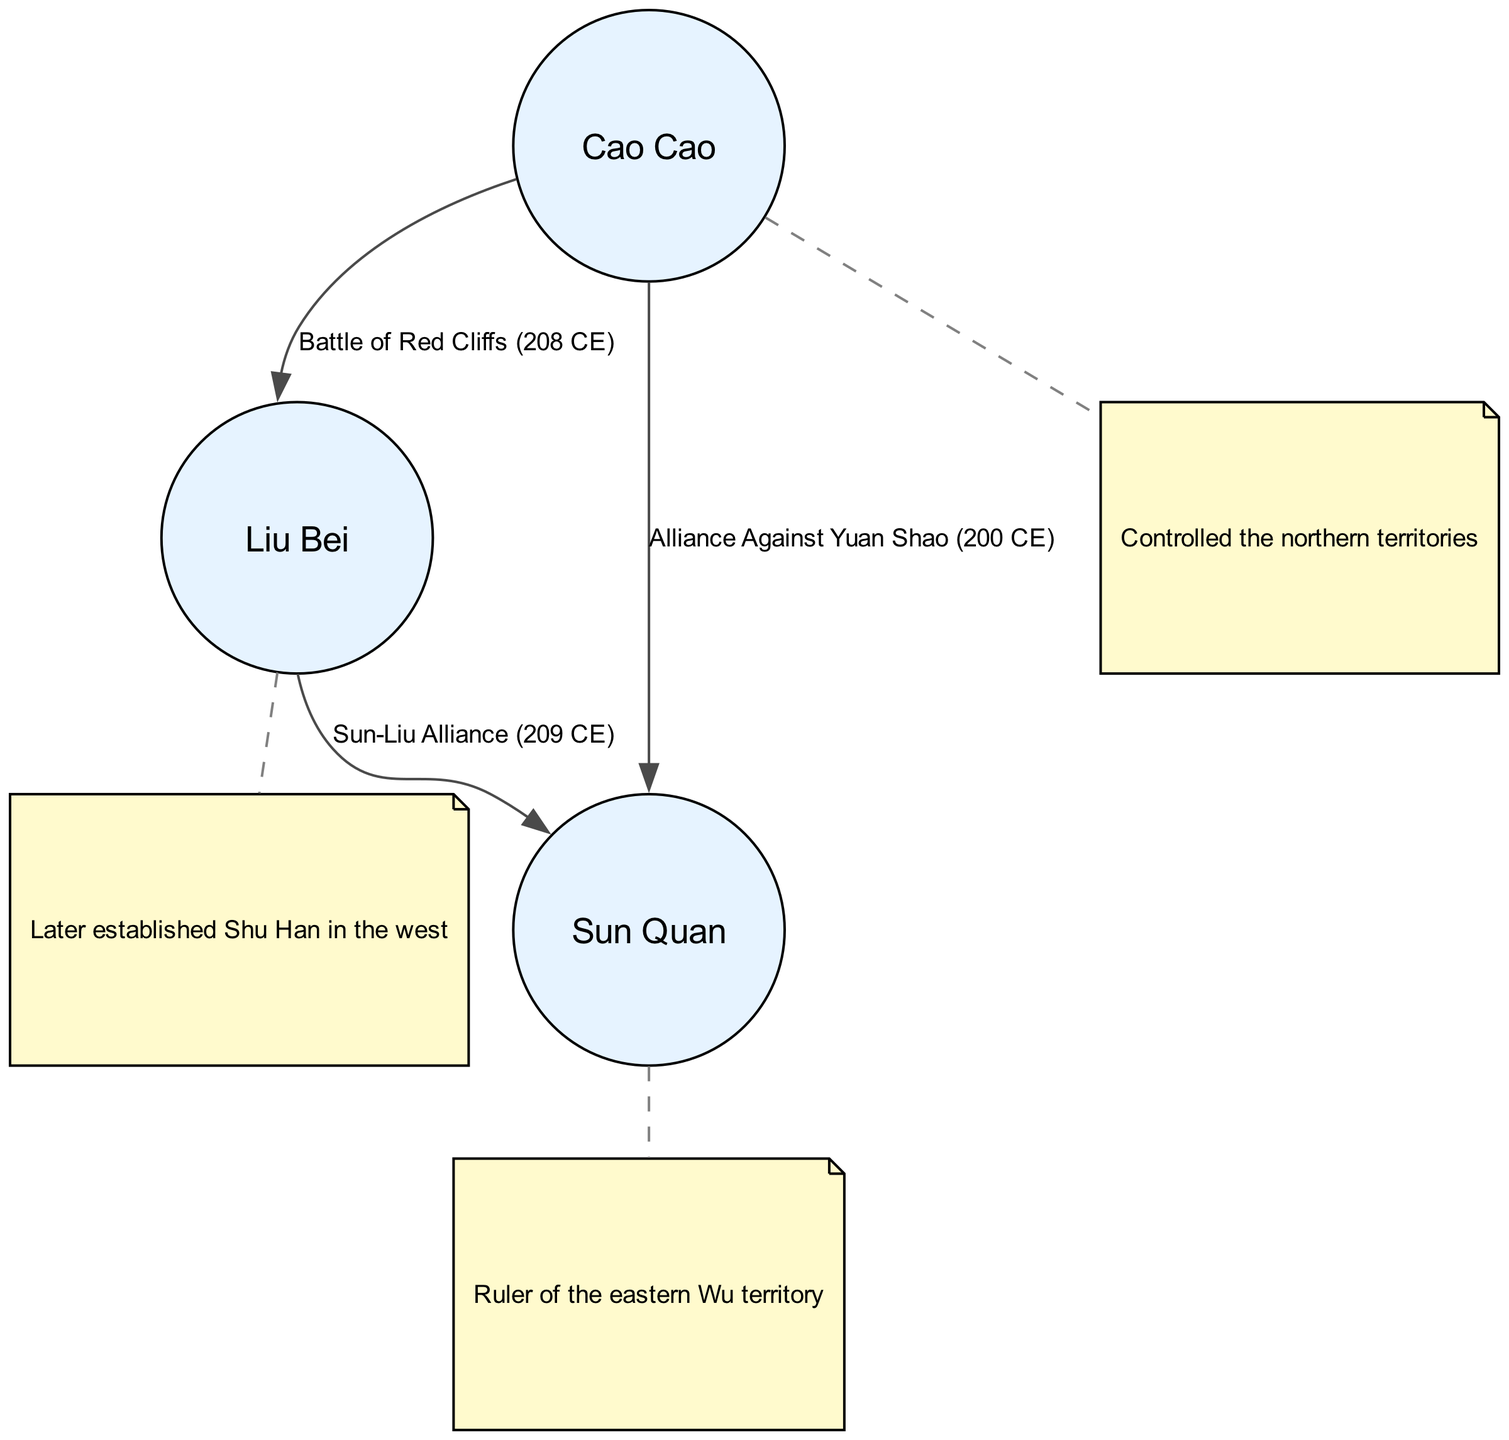What are the names of the three major warlords? The diagram includes three nodes labeled 'Cao Cao', 'Liu Bei', and 'Sun Quan', representing the major warlords of the Three Kingdoms period.
Answer: Cao Cao, Liu Bei, Sun Quan How many edges are in the diagram? The diagram has four edges: three representing battles or alliances and one for each annotation connection, leading to a total of four connections.
Answer: 4 What is the label of the edge between Cao Cao and Liu Bei? The edge connecting Cao Cao and Liu Bei is labeled 'Battle of Red Cliffs (208 CE)', indicating a significant conflict between the two warlords.
Answer: Battle of Red Cliffs (208 CE) Who controlled the northern territories? The annotation for Cao Cao states that he "Controlled the northern territories," indicating his significant geographical influence during this period.
Answer: Cao Cao What alliance was formed in 209 CE? The diagram indicates a connection labeled 'Sun-Liu Alliance (209 CE)' between Liu Bei and Sun Quan, denoting their collaboration against common enemies.
Answer: Sun-Liu Alliance (209 CE) Which warlord established Shu Han? The annotation related to Liu Bei explicitly mentions that he "Later established Shu Han in the west," indicating his role in forming a significant state in the Three Kingdoms period.
Answer: Liu Bei What year did Cao Cao and Sun Quan form an alliance? The edge labeled 'Alliance Against Yuan Shao (200 CE)' shows that Cao Cao and Sun Quan forged an alliance in the year 200 CE against a common adversary.
Answer: 200 CE Which territories did Sun Quan rule? The annotation for Sun Quan specifies that he was the "Ruler of the eastern Wu territory," identifying his geographical control during the Three Kingdoms period.
Answer: eastern Wu territory Who is depicted as the key figure in the northern territories? The diagram shows an annotation for Cao Cao stating he "Controlled the northern territories," which highlights his pivotal role in that region.
Answer: Cao Cao 